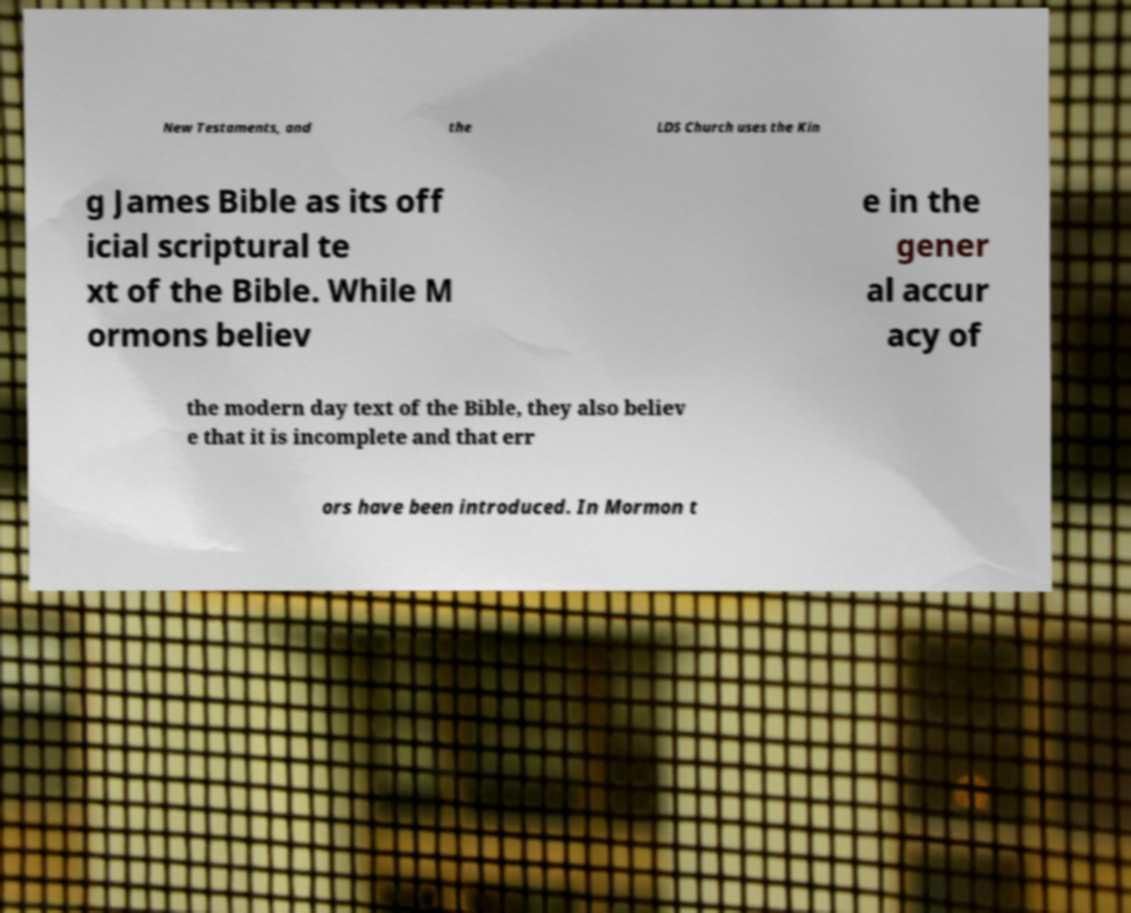Could you assist in decoding the text presented in this image and type it out clearly? New Testaments, and the LDS Church uses the Kin g James Bible as its off icial scriptural te xt of the Bible. While M ormons believ e in the gener al accur acy of the modern day text of the Bible, they also believ e that it is incomplete and that err ors have been introduced. In Mormon t 